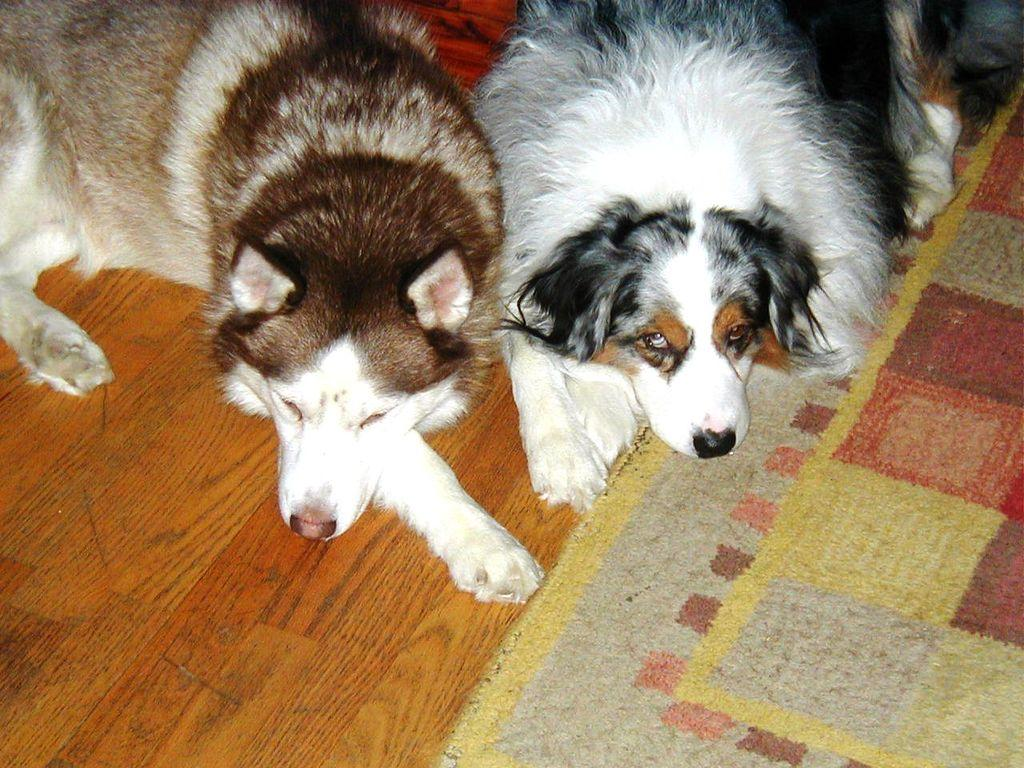How many dogs are present in the image? There are two dogs in the image. What position are the dogs in? The dogs are lying on the floor. What is on the floor in the image? There is a floor mat on the floor in the image. What type of copper material is used to make the dad's shoes in the image? There is no dad or shoes present in the image, and therefore no mention of copper material can be made. 